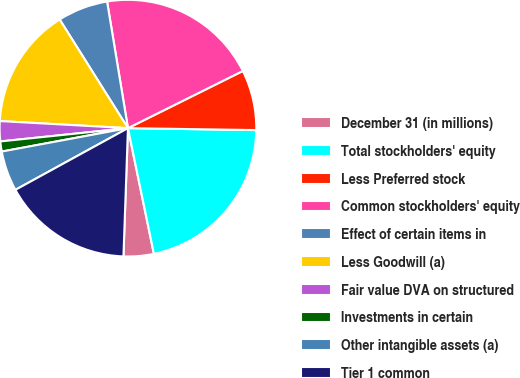Convert chart to OTSL. <chart><loc_0><loc_0><loc_500><loc_500><pie_chart><fcel>December 31 (in millions)<fcel>Total stockholders' equity<fcel>Less Preferred stock<fcel>Common stockholders' equity<fcel>Effect of certain items in<fcel>Less Goodwill (a)<fcel>Fair value DVA on structured<fcel>Investments in certain<fcel>Other intangible assets (a)<fcel>Tier 1 common<nl><fcel>3.8%<fcel>21.52%<fcel>7.59%<fcel>20.25%<fcel>6.33%<fcel>15.19%<fcel>2.53%<fcel>1.27%<fcel>5.06%<fcel>16.46%<nl></chart> 